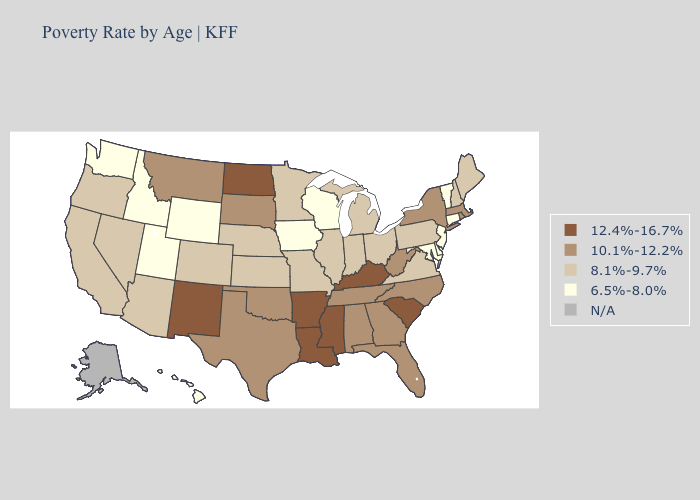What is the highest value in the USA?
Quick response, please. 12.4%-16.7%. What is the highest value in the MidWest ?
Concise answer only. 12.4%-16.7%. Which states have the highest value in the USA?
Quick response, please. Arkansas, Kentucky, Louisiana, Mississippi, New Mexico, North Dakota, South Carolina. Which states hav the highest value in the Northeast?
Answer briefly. Massachusetts, New York, Rhode Island. What is the value of Virginia?
Give a very brief answer. 8.1%-9.7%. Name the states that have a value in the range 6.5%-8.0%?
Give a very brief answer. Connecticut, Delaware, Hawaii, Idaho, Iowa, Maryland, New Jersey, Utah, Vermont, Washington, Wisconsin, Wyoming. What is the value of New York?
Quick response, please. 10.1%-12.2%. Which states hav the highest value in the Northeast?
Keep it brief. Massachusetts, New York, Rhode Island. Among the states that border South Dakota , does Minnesota have the highest value?
Give a very brief answer. No. Among the states that border Illinois , which have the lowest value?
Be succinct. Iowa, Wisconsin. Does West Virginia have the highest value in the South?
Be succinct. No. What is the value of Pennsylvania?
Keep it brief. 8.1%-9.7%. What is the lowest value in states that border Ohio?
Answer briefly. 8.1%-9.7%. 